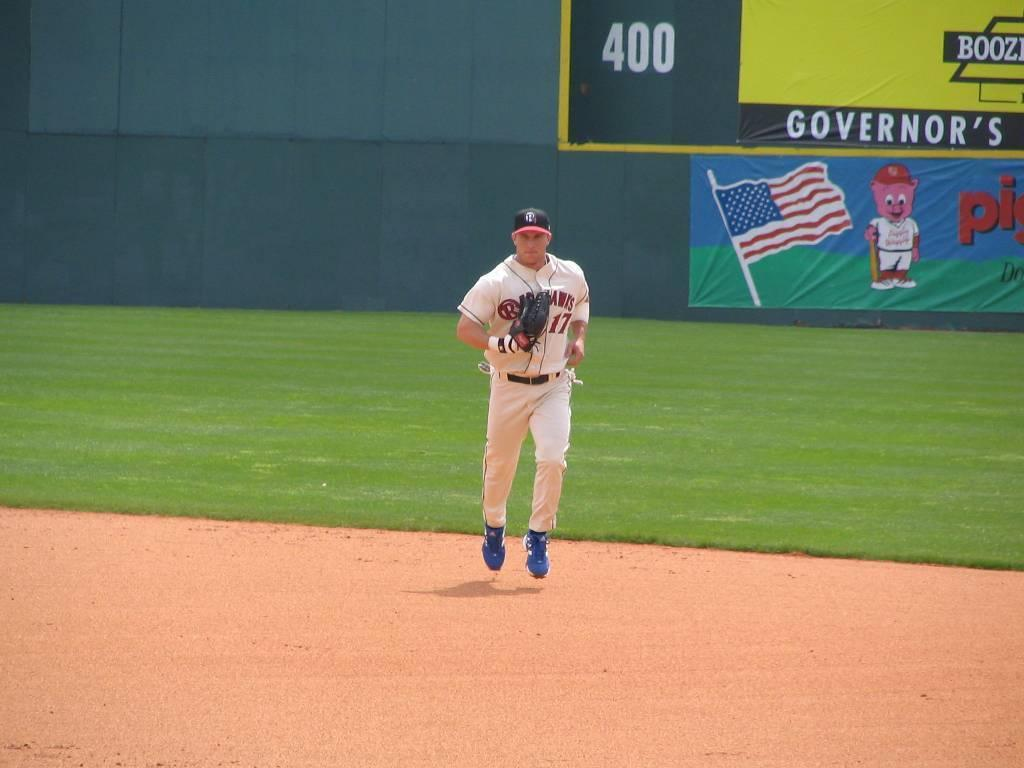<image>
Describe the image concisely. Number 17 runs off the baseball field with 400 foot wall behind him. 